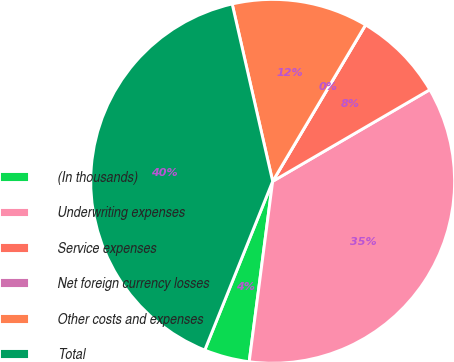Convert chart to OTSL. <chart><loc_0><loc_0><loc_500><loc_500><pie_chart><fcel>(In thousands)<fcel>Underwriting expenses<fcel>Service expenses<fcel>Net foreign currency losses<fcel>Other costs and expenses<fcel>Total<nl><fcel>4.03%<fcel>35.46%<fcel>8.07%<fcel>0.0%<fcel>12.1%<fcel>40.34%<nl></chart> 